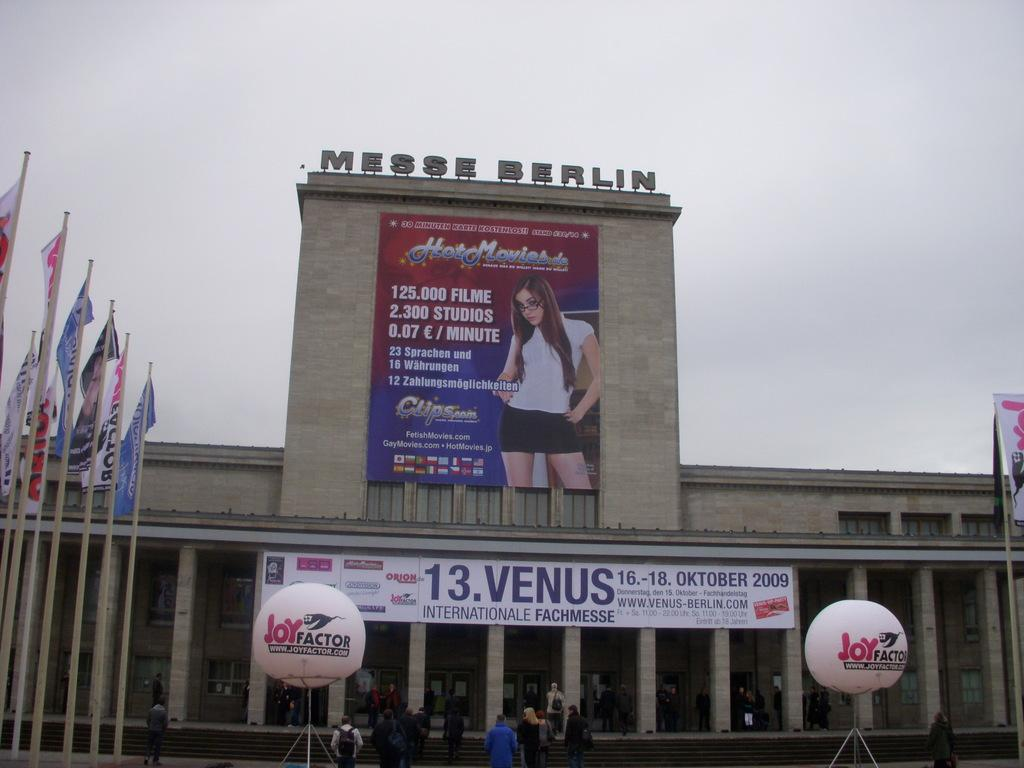<image>
Render a clear and concise summary of the photo. A large ad for Hot Movies hangs on the Messe Berlin. 